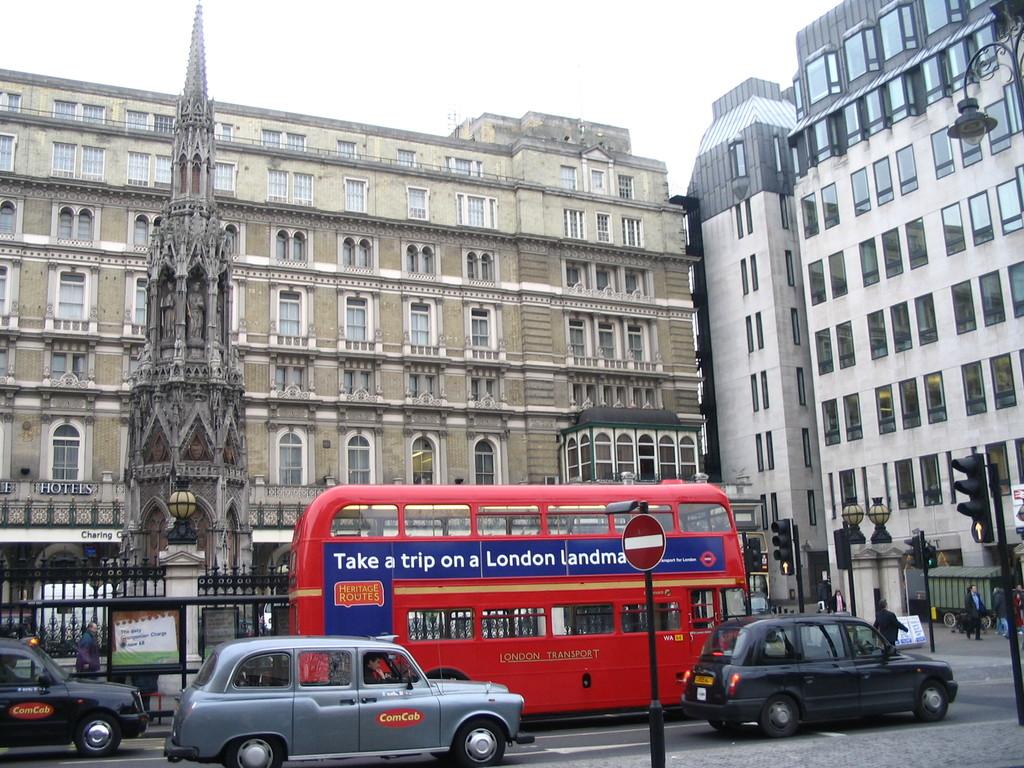What city does the bus say to take a trip too?
Provide a short and direct response. London. What city does the bus say to go to?
Give a very brief answer. London. 